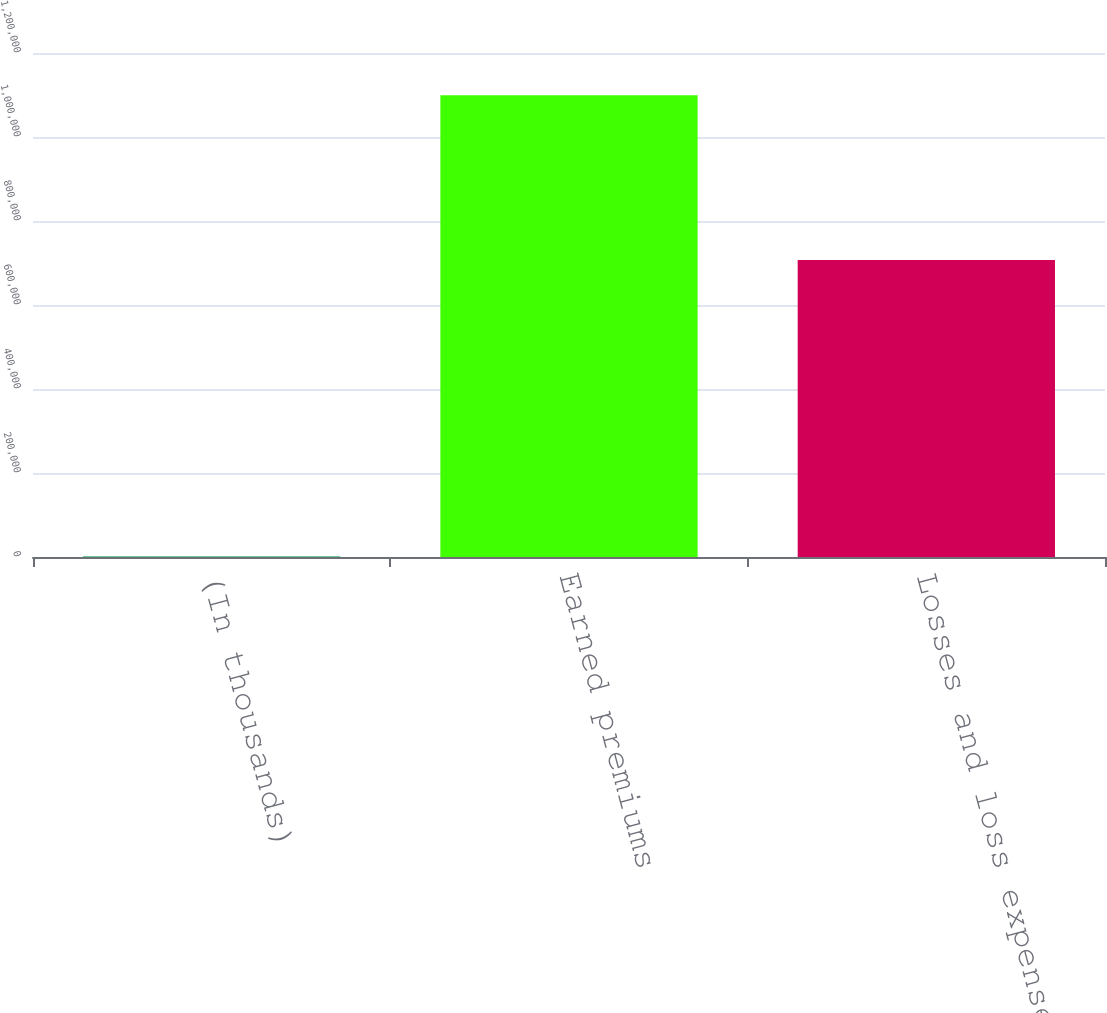Convert chart to OTSL. <chart><loc_0><loc_0><loc_500><loc_500><bar_chart><fcel>(In thousands)<fcel>Earned premiums<fcel>Losses and loss expenses<nl><fcel>2016<fcel>1.09946e+06<fcel>707336<nl></chart> 